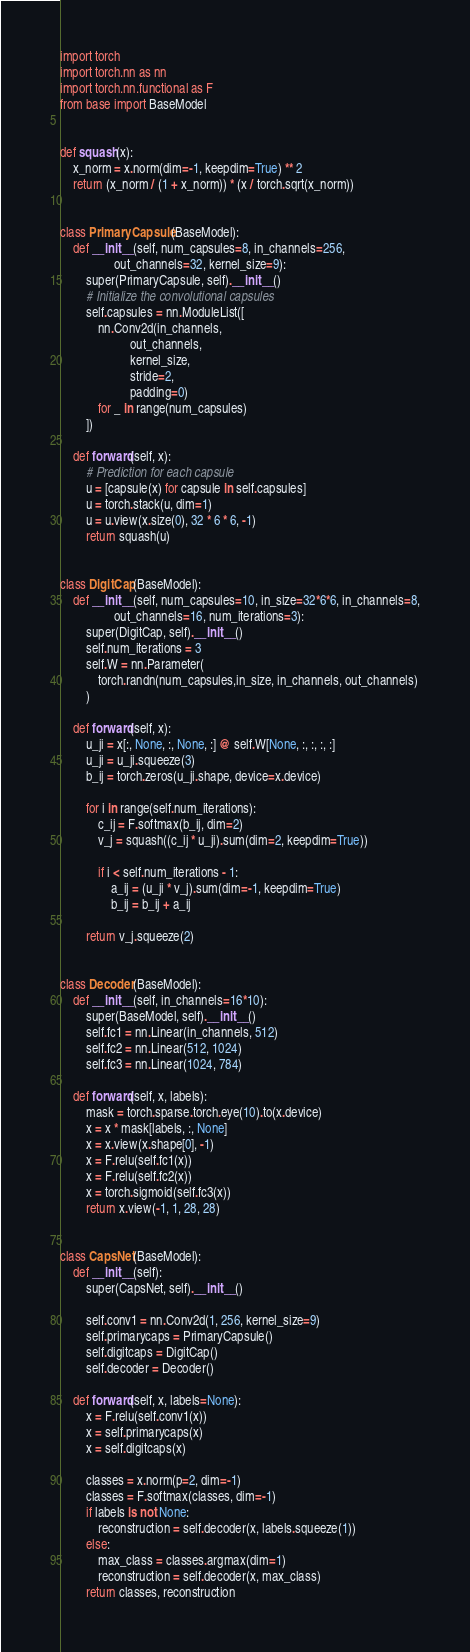Convert code to text. <code><loc_0><loc_0><loc_500><loc_500><_Python_>import torch
import torch.nn as nn
import torch.nn.functional as F
from base import BaseModel


def squash(x):
    x_norm = x.norm(dim=-1, keepdim=True) ** 2
    return (x_norm / (1 + x_norm)) * (x / torch.sqrt(x_norm))


class PrimaryCapsule(BaseModel):
    def __init__(self, num_capsules=8, in_channels=256,
                 out_channels=32, kernel_size=9):
        super(PrimaryCapsule, self).__init__()
        # Initialize the convolutional capsules
        self.capsules = nn.ModuleList([
            nn.Conv2d(in_channels,
                      out_channels,
                      kernel_size,
                      stride=2,
                      padding=0)
            for _ in range(num_capsules)
        ])

    def forward(self, x):
        # Prediction for each capsule
        u = [capsule(x) for capsule in self.capsules]
        u = torch.stack(u, dim=1)
        u = u.view(x.size(0), 32 * 6 * 6, -1)
        return squash(u)


class DigitCap(BaseModel):
    def __init__(self, num_capsules=10, in_size=32*6*6, in_channels=8,
                 out_channels=16, num_iterations=3):
        super(DigitCap, self).__init__()
        self.num_iterations = 3
        self.W = nn.Parameter(
            torch.randn(num_capsules,in_size, in_channels, out_channels)
        )

    def forward(self, x):
        u_ji = x[:, None, :, None, :] @ self.W[None, :, :, :, :]
        u_ji = u_ji.squeeze(3)
        b_ij = torch.zeros(u_ji.shape, device=x.device)

        for i in range(self.num_iterations):
            c_ij = F.softmax(b_ij, dim=2)
            v_j = squash((c_ij * u_ji).sum(dim=2, keepdim=True))

            if i < self.num_iterations - 1:
                a_ij = (u_ji * v_j).sum(dim=-1, keepdim=True)
                b_ij = b_ij + a_ij

        return v_j.squeeze(2)


class Decoder(BaseModel):
    def __init__(self, in_channels=16*10):
        super(BaseModel, self).__init__()
        self.fc1 = nn.Linear(in_channels, 512)
        self.fc2 = nn.Linear(512, 1024)
        self.fc3 = nn.Linear(1024, 784)

    def forward(self, x, labels):
        mask = torch.sparse.torch.eye(10).to(x.device)
        x = x * mask[labels, :, None]
        x = x.view(x.shape[0], -1)
        x = F.relu(self.fc1(x))
        x = F.relu(self.fc2(x))
        x = torch.sigmoid(self.fc3(x))
        return x.view(-1, 1, 28, 28)


class CapsNet(BaseModel):
    def __init__(self):
        super(CapsNet, self).__init__()

        self.conv1 = nn.Conv2d(1, 256, kernel_size=9)
        self.primarycaps = PrimaryCapsule()
        self.digitcaps = DigitCap()
        self.decoder = Decoder()

    def forward(self, x, labels=None):
        x = F.relu(self.conv1(x))
        x = self.primarycaps(x)
        x = self.digitcaps(x)

        classes = x.norm(p=2, dim=-1)
        classes = F.softmax(classes, dim=-1)
        if labels is not None:
            reconstruction = self.decoder(x, labels.squeeze(1))
        else:
            max_class = classes.argmax(dim=1)
            reconstruction = self.decoder(x, max_class)
        return classes, reconstruction

</code> 